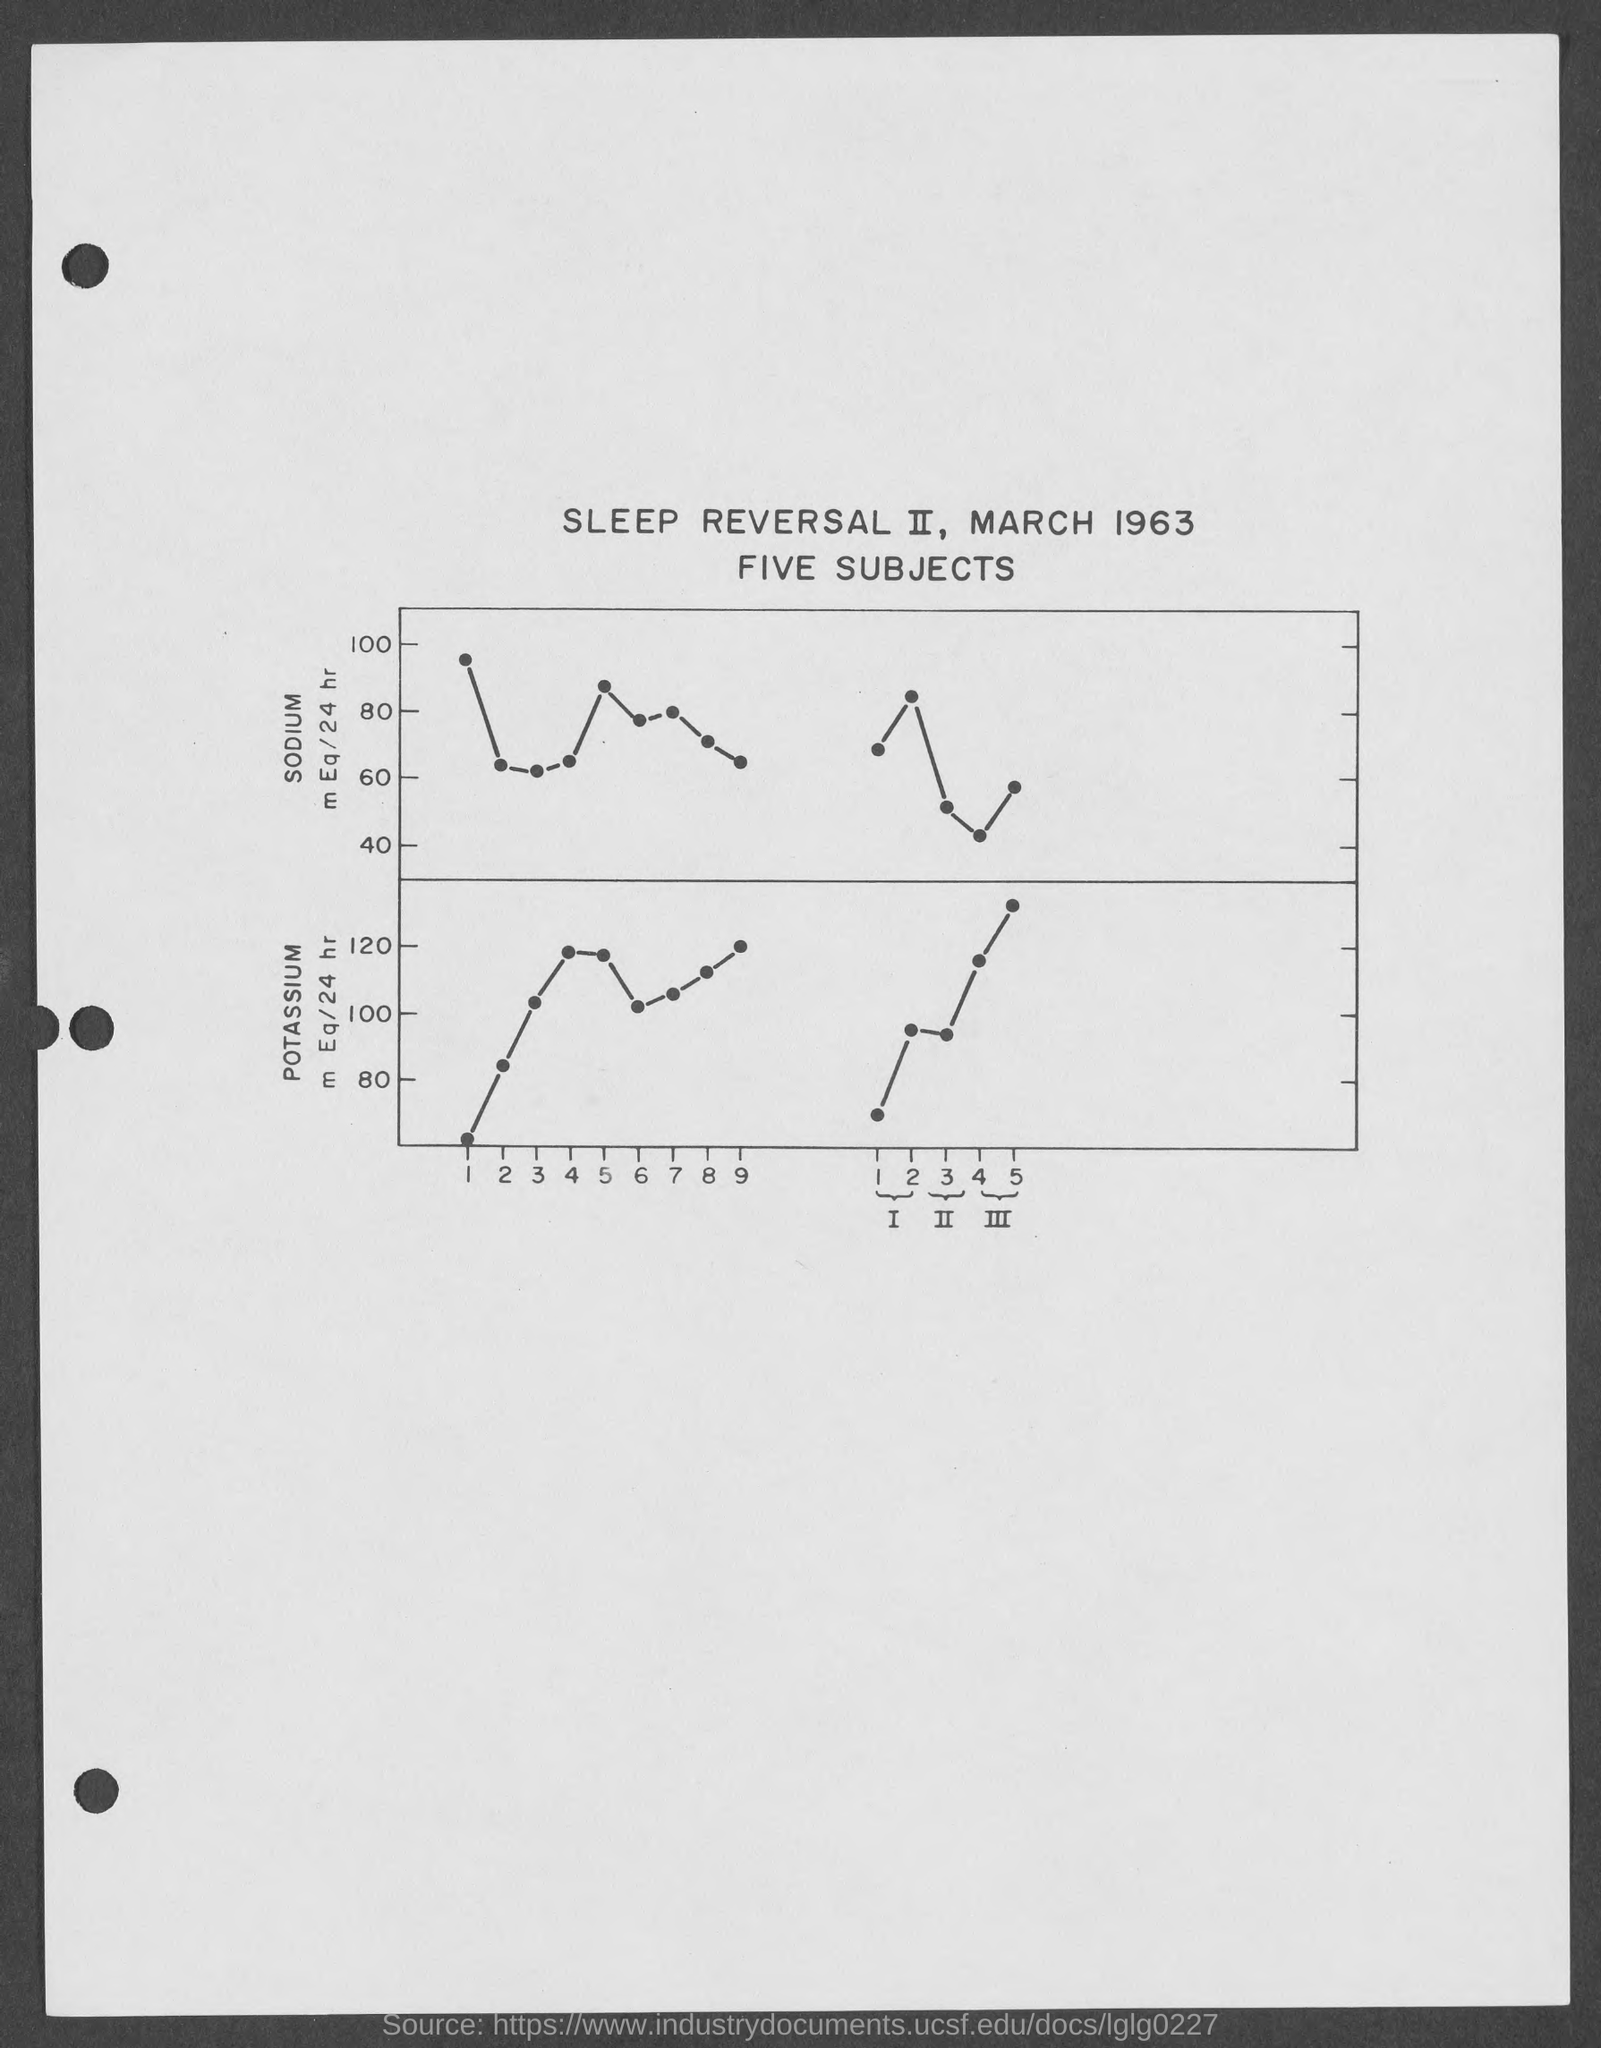What is the name of the element written on the Y-axis of the first graph ?
Make the answer very short. SODIUM. What is the name of the element written on the Y-axis of the second graph ?
Provide a succinct answer. Potassium. Which month is mentioned in the title of the graph ?
Provide a succinct answer. March. Which is the year given in the title of the graph ?
Make the answer very short. 1963. 